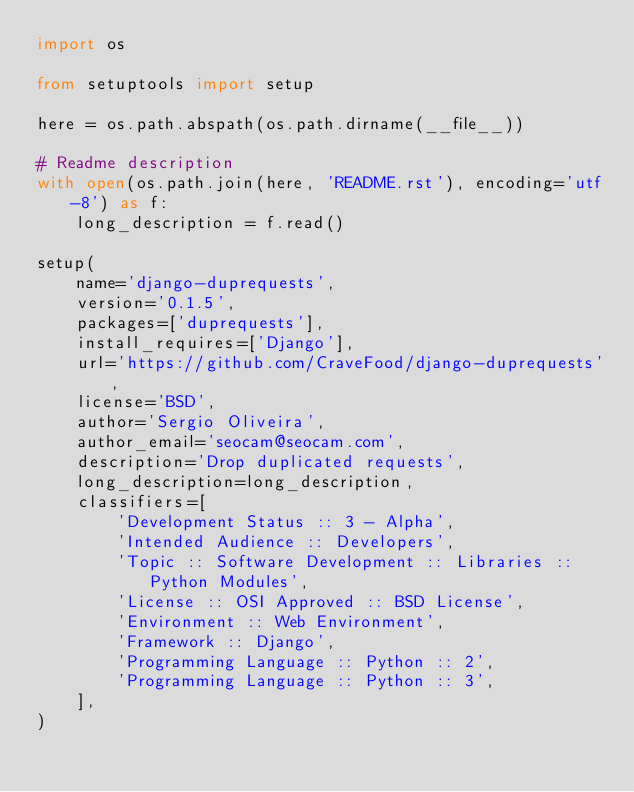<code> <loc_0><loc_0><loc_500><loc_500><_Python_>import os

from setuptools import setup

here = os.path.abspath(os.path.dirname(__file__))

# Readme description
with open(os.path.join(here, 'README.rst'), encoding='utf-8') as f:
    long_description = f.read()

setup(
    name='django-duprequests',
    version='0.1.5',
    packages=['duprequests'],
    install_requires=['Django'],
    url='https://github.com/CraveFood/django-duprequests',
    license='BSD',
    author='Sergio Oliveira',
    author_email='seocam@seocam.com',
    description='Drop duplicated requests',
    long_description=long_description,
    classifiers=[
        'Development Status :: 3 - Alpha',
        'Intended Audience :: Developers',
        'Topic :: Software Development :: Libraries :: Python Modules',
        'License :: OSI Approved :: BSD License',
        'Environment :: Web Environment',
        'Framework :: Django',
        'Programming Language :: Python :: 2',
        'Programming Language :: Python :: 3',
    ],
)
</code> 